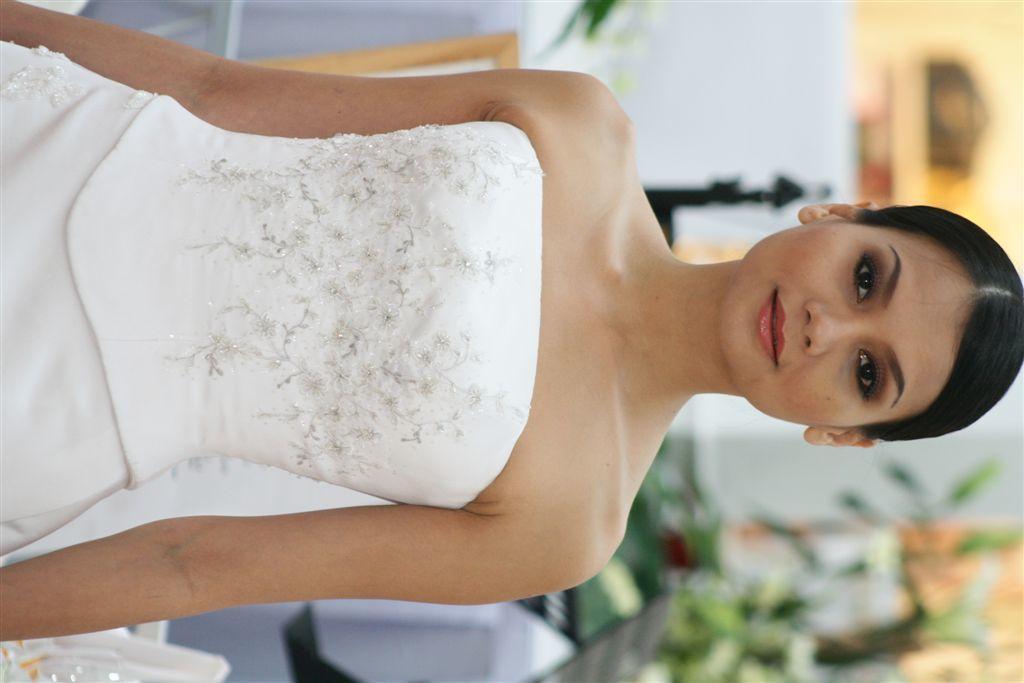Can you describe this image briefly? In this image there is a woman. She is wearing a white dress. She is smiling. Behind her there are tables. There is a cloth spread on the table. There are house plants and a candle holder on the table. The background is blurry. 